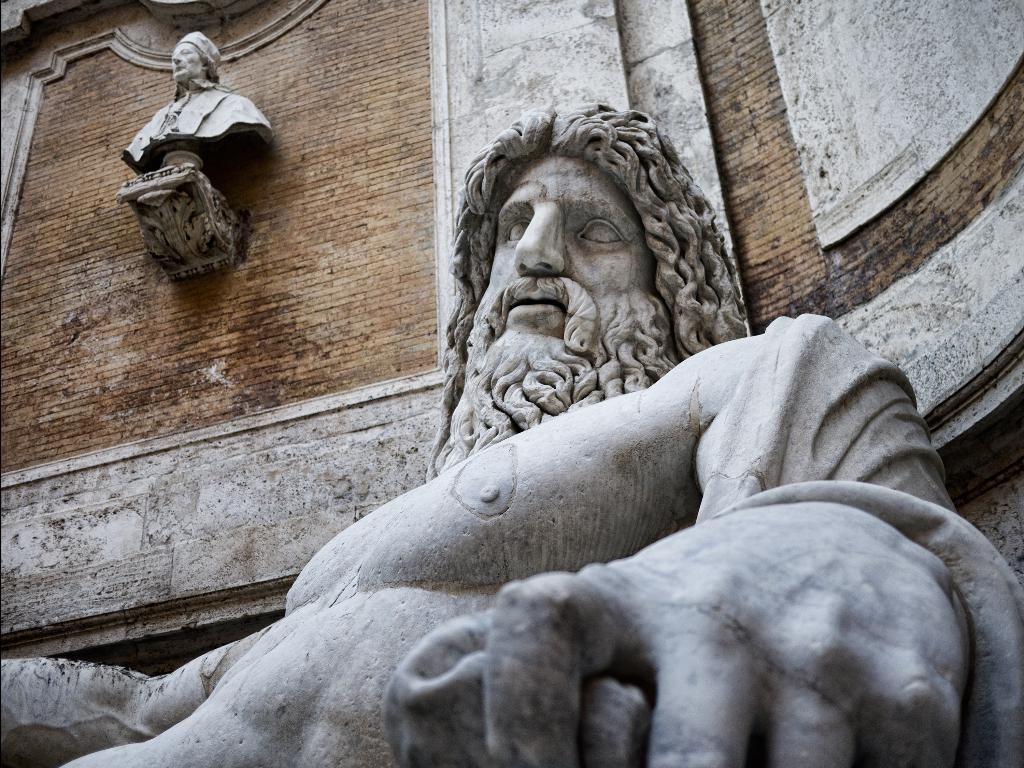What type of objects can be seen in the image? There are statues in the image. What architectural feature is present in the image? There is a wall in the image. What type of lace can be seen on the cabbage in the image? There is no cabbage or lace present in the image; it only features statues and a wall. 